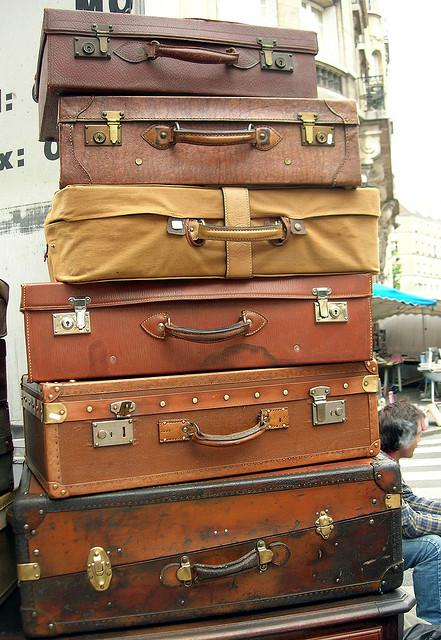What is the building at the back?

Choices:
A) shopping mall
B) residential building
C) hotel
D) office building hotel 